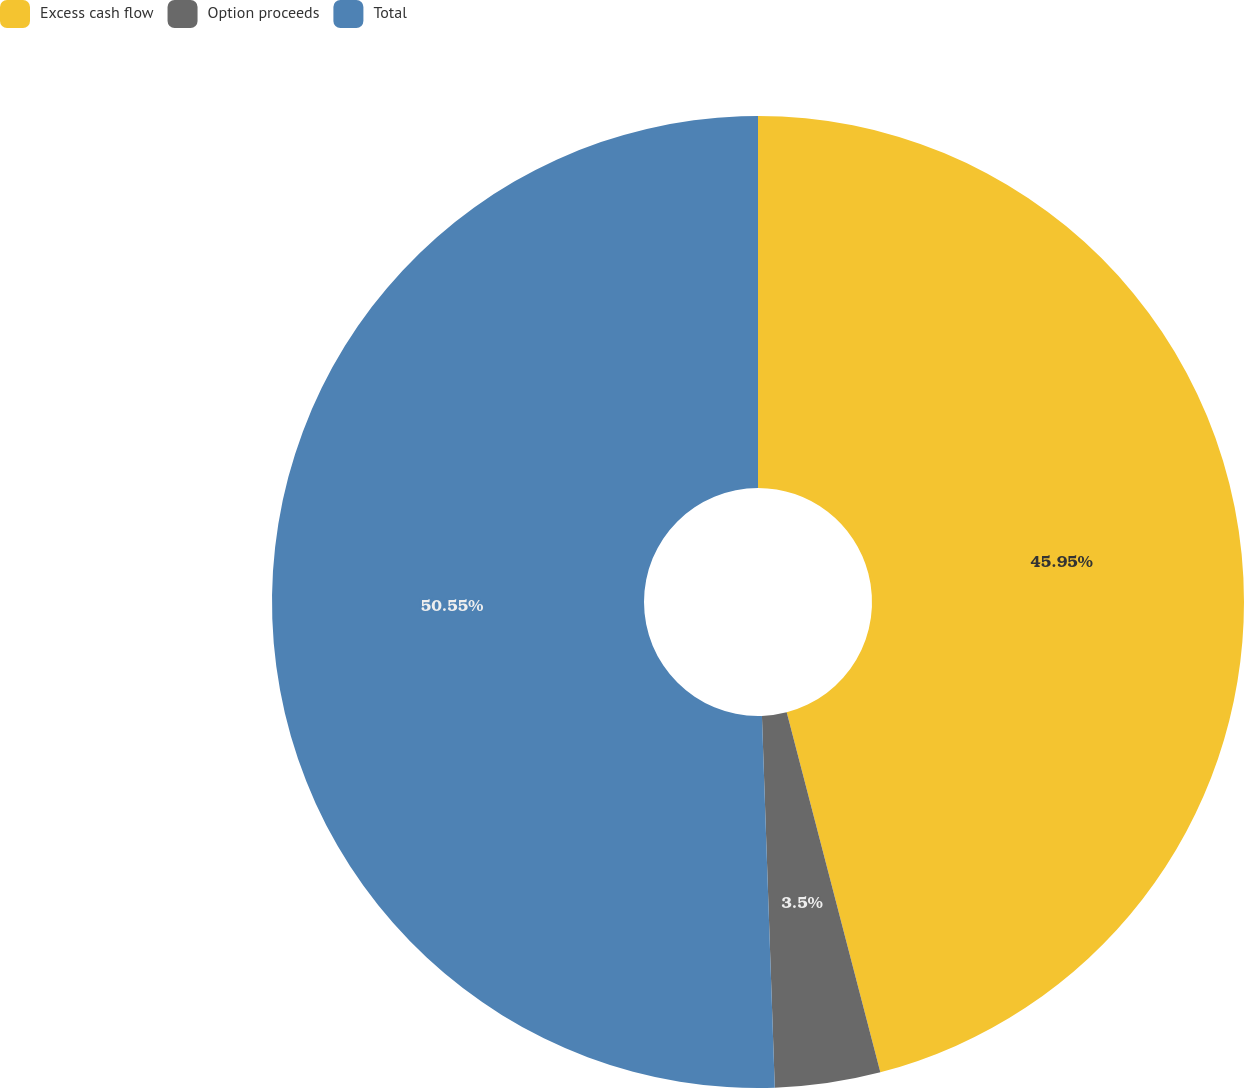Convert chart to OTSL. <chart><loc_0><loc_0><loc_500><loc_500><pie_chart><fcel>Excess cash flow<fcel>Option proceeds<fcel>Total<nl><fcel>45.95%<fcel>3.5%<fcel>50.55%<nl></chart> 